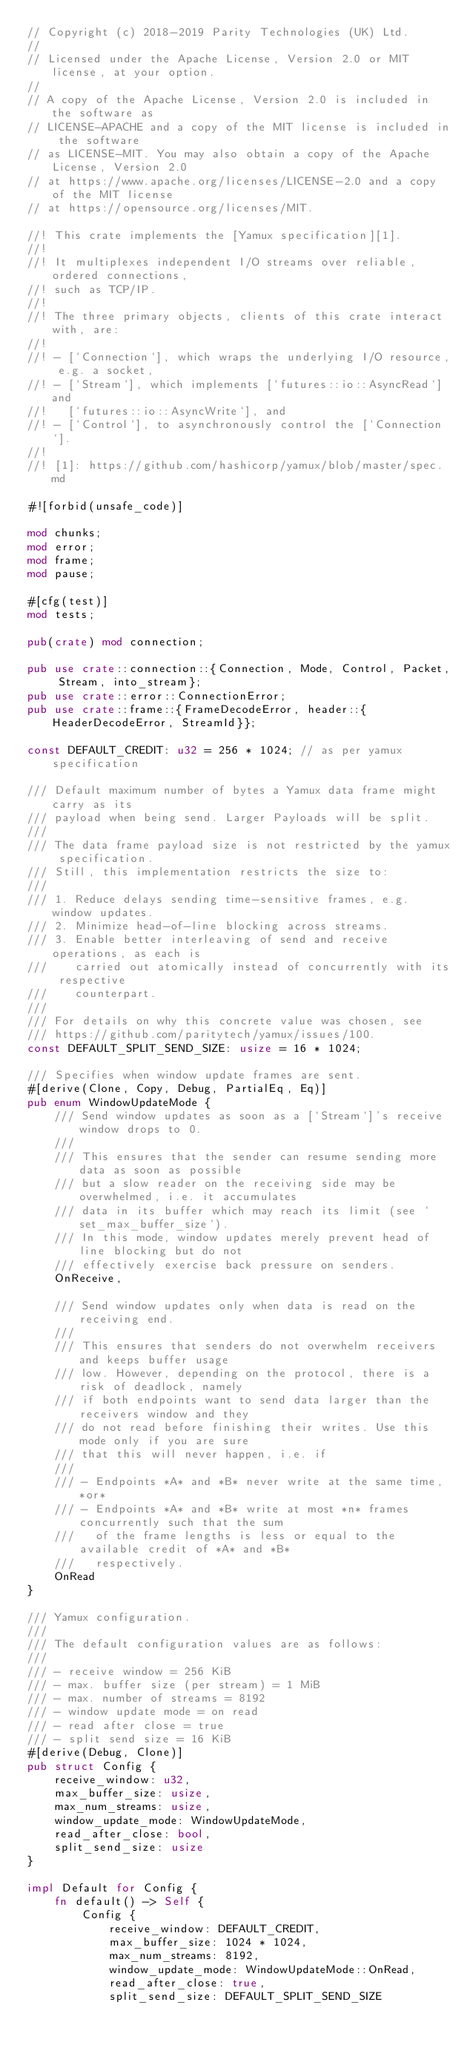<code> <loc_0><loc_0><loc_500><loc_500><_Rust_>// Copyright (c) 2018-2019 Parity Technologies (UK) Ltd.
//
// Licensed under the Apache License, Version 2.0 or MIT license, at your option.
//
// A copy of the Apache License, Version 2.0 is included in the software as
// LICENSE-APACHE and a copy of the MIT license is included in the software
// as LICENSE-MIT. You may also obtain a copy of the Apache License, Version 2.0
// at https://www.apache.org/licenses/LICENSE-2.0 and a copy of the MIT license
// at https://opensource.org/licenses/MIT.

//! This crate implements the [Yamux specification][1].
//!
//! It multiplexes independent I/O streams over reliable, ordered connections,
//! such as TCP/IP.
//!
//! The three primary objects, clients of this crate interact with, are:
//!
//! - [`Connection`], which wraps the underlying I/O resource, e.g. a socket,
//! - [`Stream`], which implements [`futures::io::AsyncRead`] and
//!   [`futures::io::AsyncWrite`], and
//! - [`Control`], to asynchronously control the [`Connection`].
//!
//! [1]: https://github.com/hashicorp/yamux/blob/master/spec.md

#![forbid(unsafe_code)]

mod chunks;
mod error;
mod frame;
mod pause;

#[cfg(test)]
mod tests;

pub(crate) mod connection;

pub use crate::connection::{Connection, Mode, Control, Packet, Stream, into_stream};
pub use crate::error::ConnectionError;
pub use crate::frame::{FrameDecodeError, header::{HeaderDecodeError, StreamId}};

const DEFAULT_CREDIT: u32 = 256 * 1024; // as per yamux specification

/// Default maximum number of bytes a Yamux data frame might carry as its
/// payload when being send. Larger Payloads will be split.
///
/// The data frame payload size is not restricted by the yamux specification.
/// Still, this implementation restricts the size to:
///
/// 1. Reduce delays sending time-sensitive frames, e.g. window updates.
/// 2. Minimize head-of-line blocking across streams.
/// 3. Enable better interleaving of send and receive operations, as each is
///    carried out atomically instead of concurrently with its respective
///    counterpart.
///
/// For details on why this concrete value was chosen, see
/// https://github.com/paritytech/yamux/issues/100.
const DEFAULT_SPLIT_SEND_SIZE: usize = 16 * 1024;

/// Specifies when window update frames are sent.
#[derive(Clone, Copy, Debug, PartialEq, Eq)]
pub enum WindowUpdateMode {
    /// Send window updates as soon as a [`Stream`]'s receive window drops to 0.
    ///
    /// This ensures that the sender can resume sending more data as soon as possible
    /// but a slow reader on the receiving side may be overwhelmed, i.e. it accumulates
    /// data in its buffer which may reach its limit (see `set_max_buffer_size`).
    /// In this mode, window updates merely prevent head of line blocking but do not
    /// effectively exercise back pressure on senders.
    OnReceive,

    /// Send window updates only when data is read on the receiving end.
    ///
    /// This ensures that senders do not overwhelm receivers and keeps buffer usage
    /// low. However, depending on the protocol, there is a risk of deadlock, namely
    /// if both endpoints want to send data larger than the receivers window and they
    /// do not read before finishing their writes. Use this mode only if you are sure
    /// that this will never happen, i.e. if
    ///
    /// - Endpoints *A* and *B* never write at the same time, *or*
    /// - Endpoints *A* and *B* write at most *n* frames concurrently such that the sum
    ///   of the frame lengths is less or equal to the available credit of *A* and *B*
    ///   respectively.
    OnRead
}

/// Yamux configuration.
///
/// The default configuration values are as follows:
///
/// - receive window = 256 KiB
/// - max. buffer size (per stream) = 1 MiB
/// - max. number of streams = 8192
/// - window update mode = on read
/// - read after close = true
/// - split send size = 16 KiB
#[derive(Debug, Clone)]
pub struct Config {
    receive_window: u32,
    max_buffer_size: usize,
    max_num_streams: usize,
    window_update_mode: WindowUpdateMode,
    read_after_close: bool,
    split_send_size: usize
}

impl Default for Config {
    fn default() -> Self {
        Config {
            receive_window: DEFAULT_CREDIT,
            max_buffer_size: 1024 * 1024,
            max_num_streams: 8192,
            window_update_mode: WindowUpdateMode::OnRead,
            read_after_close: true,
            split_send_size: DEFAULT_SPLIT_SEND_SIZE</code> 